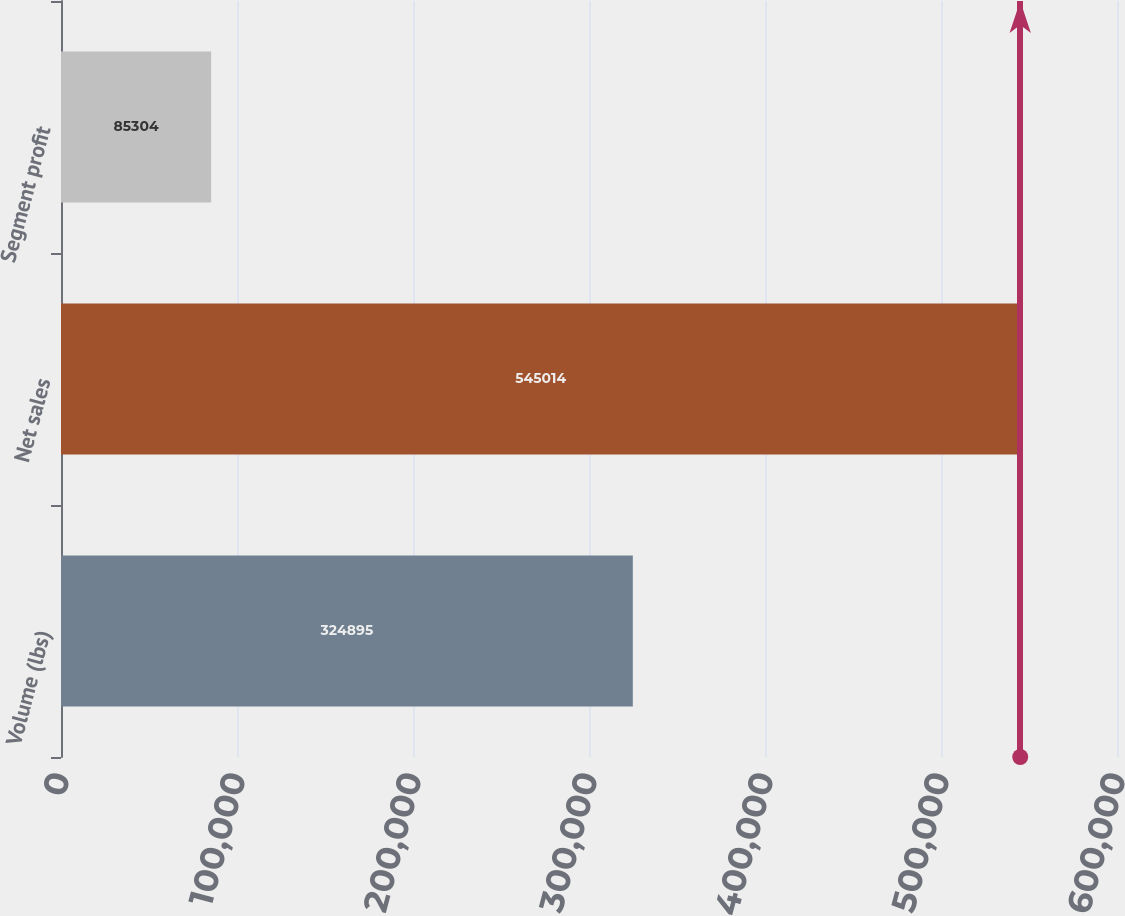Convert chart. <chart><loc_0><loc_0><loc_500><loc_500><bar_chart><fcel>Volume (lbs)<fcel>Net sales<fcel>Segment profit<nl><fcel>324895<fcel>545014<fcel>85304<nl></chart> 